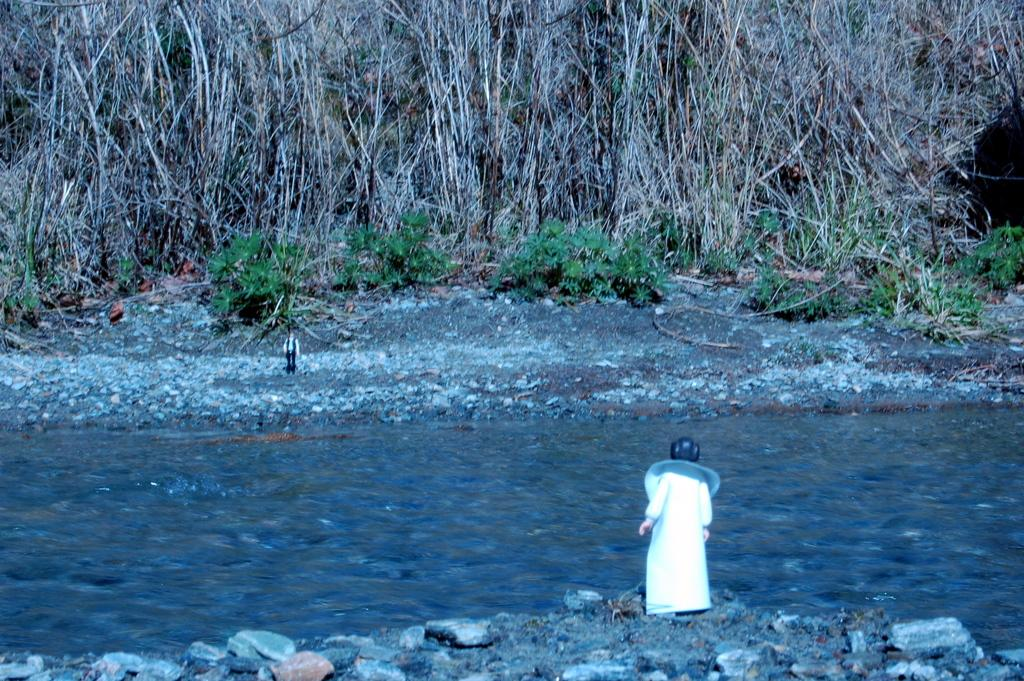What is the main feature of the image? There is a river in the image. What can be seen on the sides of the river? There are rocks on the sides of the river. Are there any people in the image? Yes, there are two persons on the sides of the river. What is visible in the background of the image? There are trees and plants in the background of the image. What type of music can be heard coming from the river in the image? There is no music present in the image, as it features a river with rocks, two persons, and a background of trees and plants. 